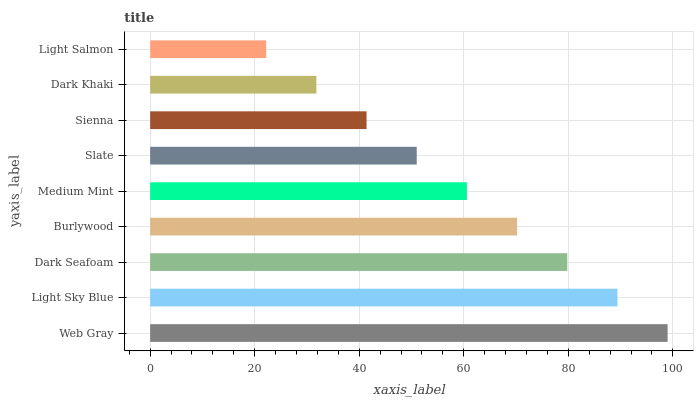Is Light Salmon the minimum?
Answer yes or no. Yes. Is Web Gray the maximum?
Answer yes or no. Yes. Is Light Sky Blue the minimum?
Answer yes or no. No. Is Light Sky Blue the maximum?
Answer yes or no. No. Is Web Gray greater than Light Sky Blue?
Answer yes or no. Yes. Is Light Sky Blue less than Web Gray?
Answer yes or no. Yes. Is Light Sky Blue greater than Web Gray?
Answer yes or no. No. Is Web Gray less than Light Sky Blue?
Answer yes or no. No. Is Medium Mint the high median?
Answer yes or no. Yes. Is Medium Mint the low median?
Answer yes or no. Yes. Is Burlywood the high median?
Answer yes or no. No. Is Dark Khaki the low median?
Answer yes or no. No. 